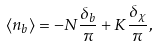Convert formula to latex. <formula><loc_0><loc_0><loc_500><loc_500>\langle n _ { b } \rangle = - N \frac { \delta _ { b } } { \pi } + K \frac { \delta _ { \chi } } { \pi } ,</formula> 